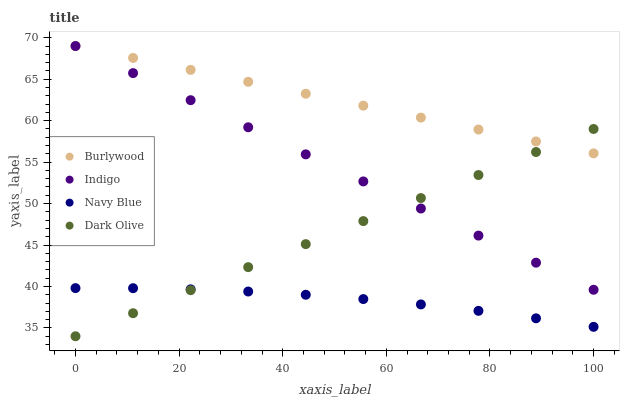Does Navy Blue have the minimum area under the curve?
Answer yes or no. Yes. Does Burlywood have the maximum area under the curve?
Answer yes or no. Yes. Does Dark Olive have the minimum area under the curve?
Answer yes or no. No. Does Dark Olive have the maximum area under the curve?
Answer yes or no. No. Is Dark Olive the smoothest?
Answer yes or no. Yes. Is Navy Blue the roughest?
Answer yes or no. Yes. Is Navy Blue the smoothest?
Answer yes or no. No. Is Dark Olive the roughest?
Answer yes or no. No. Does Dark Olive have the lowest value?
Answer yes or no. Yes. Does Navy Blue have the lowest value?
Answer yes or no. No. Does Indigo have the highest value?
Answer yes or no. Yes. Does Dark Olive have the highest value?
Answer yes or no. No. Is Navy Blue less than Indigo?
Answer yes or no. Yes. Is Burlywood greater than Navy Blue?
Answer yes or no. Yes. Does Dark Olive intersect Indigo?
Answer yes or no. Yes. Is Dark Olive less than Indigo?
Answer yes or no. No. Is Dark Olive greater than Indigo?
Answer yes or no. No. Does Navy Blue intersect Indigo?
Answer yes or no. No. 